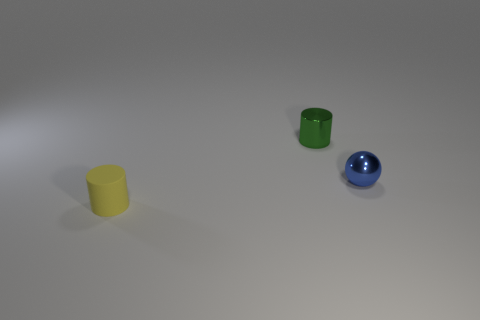How many objects are either big brown rubber cubes or tiny cylinders behind the small yellow cylinder?
Your answer should be compact. 1. What color is the tiny ball?
Provide a short and direct response. Blue. There is a cylinder that is to the right of the yellow matte cylinder; what is its color?
Give a very brief answer. Green. What number of things are right of the cylinder that is to the left of the green object?
Provide a succinct answer. 2. There is a blue thing; does it have the same size as the thing behind the blue metallic object?
Give a very brief answer. Yes. Is there a yellow rubber thing that has the same size as the blue thing?
Offer a very short reply. Yes. What number of things are either small blue spheres or small purple balls?
Your answer should be very brief. 1. Is there a yellow thing that has the same shape as the small green metal thing?
Your answer should be compact. Yes. Are there fewer tiny metallic cylinders that are right of the small yellow object than small blue balls?
Ensure brevity in your answer.  No. Does the small rubber object have the same shape as the tiny green thing?
Offer a very short reply. Yes. 